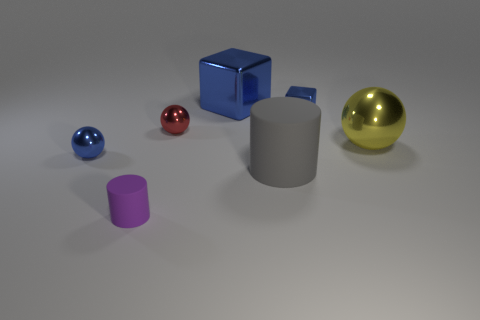Add 3 large metal things. How many objects exist? 10 Subtract all yellow metallic spheres. How many spheres are left? 2 Subtract 3 spheres. How many spheres are left? 0 Subtract all spheres. How many objects are left? 4 Add 4 gray balls. How many gray balls exist? 4 Subtract all blue spheres. How many spheres are left? 2 Subtract 0 purple blocks. How many objects are left? 7 Subtract all gray cubes. Subtract all purple balls. How many cubes are left? 2 Subtract all cyan spheres. How many yellow cubes are left? 0 Subtract all tiny red shiny balls. Subtract all big blocks. How many objects are left? 5 